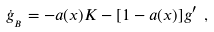Convert formula to latex. <formula><loc_0><loc_0><loc_500><loc_500>\dot { g } _ { _ { B } } = - a ( x ) { K } - [ 1 - a ( x ) ] { g } ^ { \prime } \ ,</formula> 